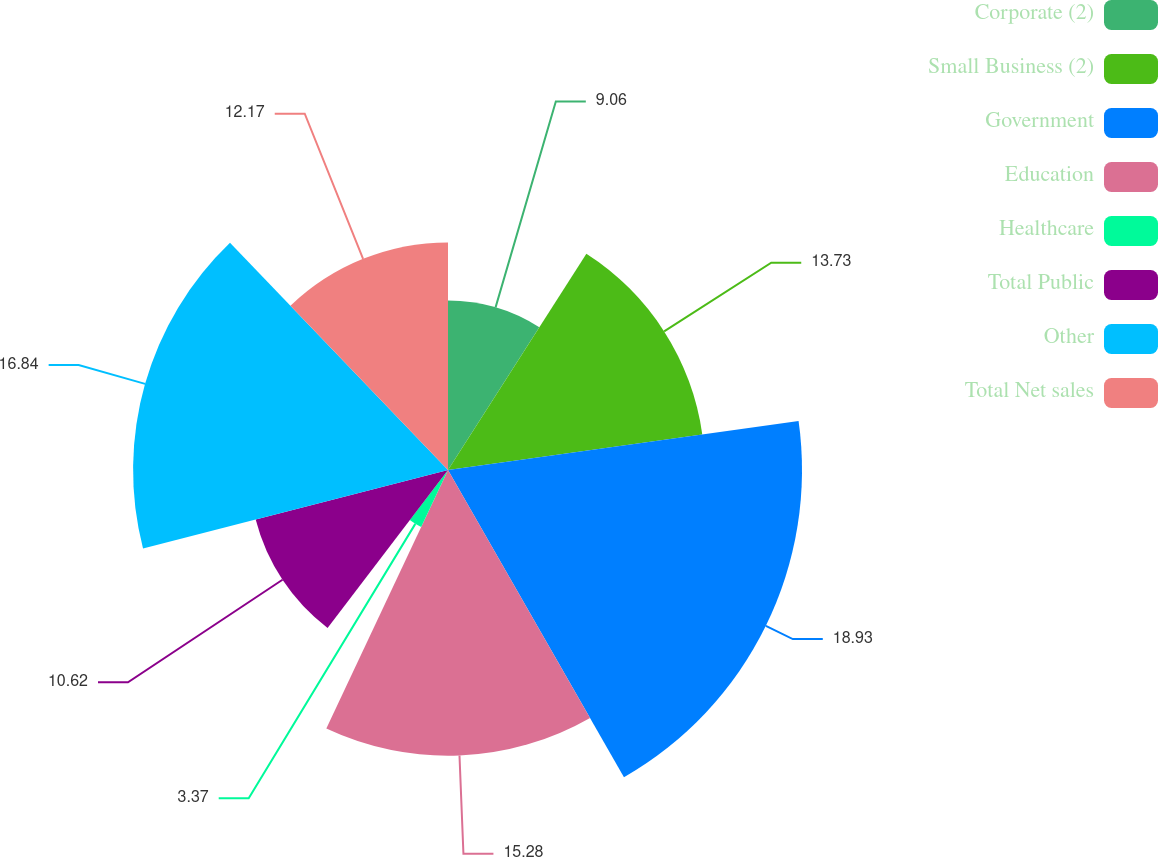Convert chart to OTSL. <chart><loc_0><loc_0><loc_500><loc_500><pie_chart><fcel>Corporate (2)<fcel>Small Business (2)<fcel>Government<fcel>Education<fcel>Healthcare<fcel>Total Public<fcel>Other<fcel>Total Net sales<nl><fcel>9.06%<fcel>13.73%<fcel>18.93%<fcel>15.28%<fcel>3.37%<fcel>10.62%<fcel>16.84%<fcel>12.17%<nl></chart> 